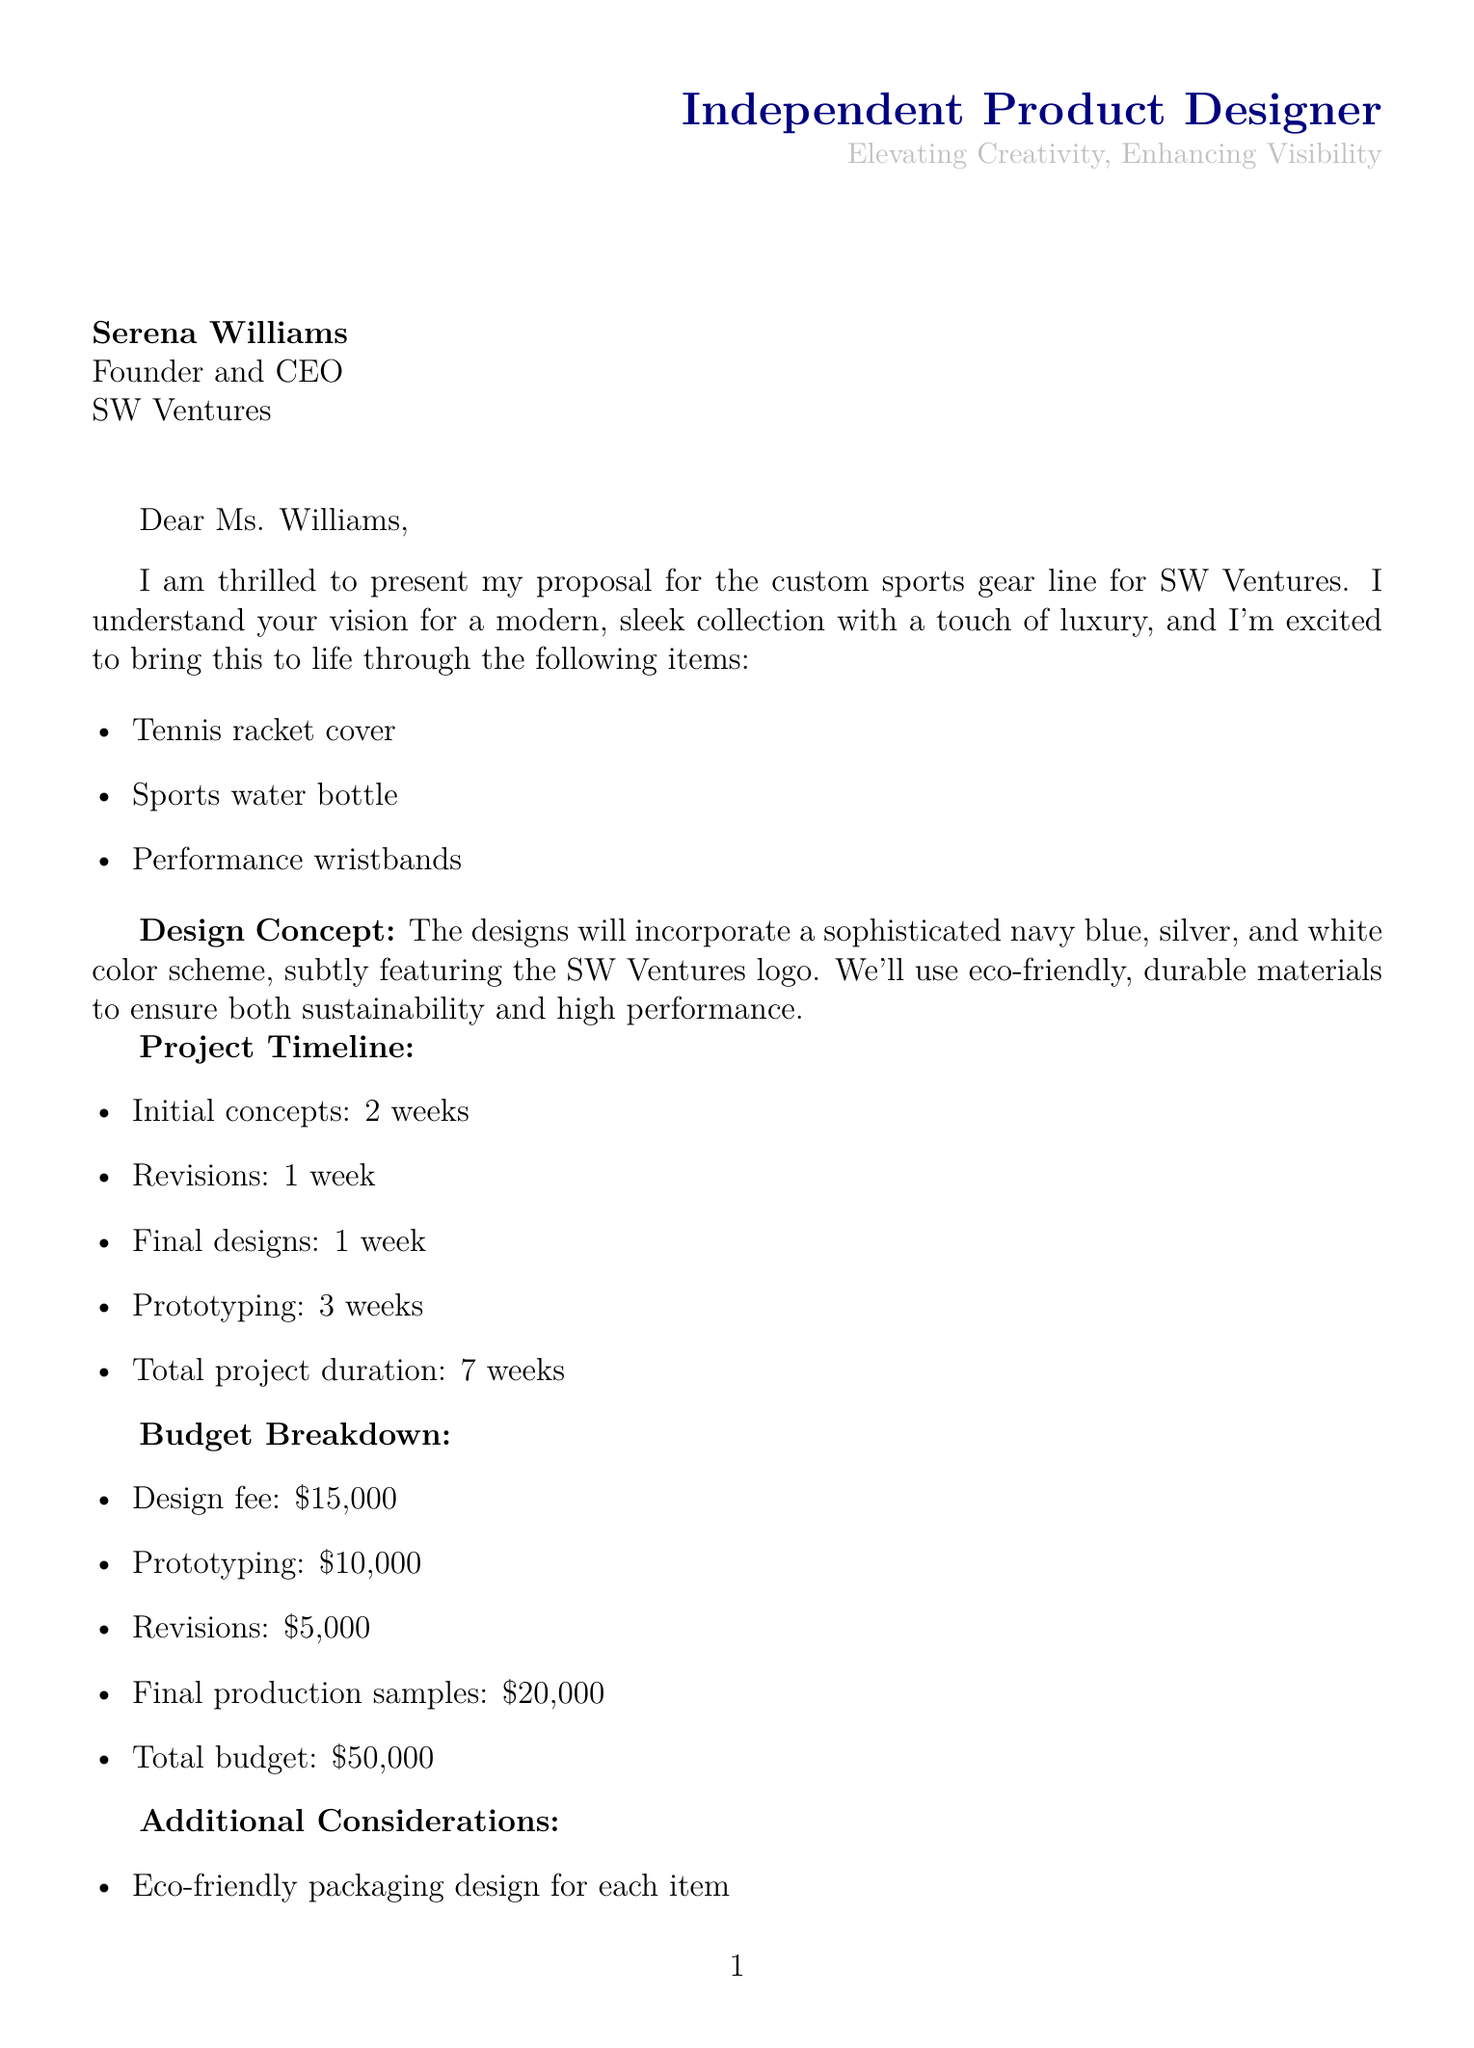What is the client's name? The client's name is mentioned at the beginning of the document.
Answer: Serena Williams What is the total budget for the project? The total budget is provided in the budget section of the document.
Answer: $50,000 How long will it take to complete the initial concepts? The timeline specifies the duration for initial concepts.
Answer: 2 weeks What is the design fee? The budget breakdown includes the design fee specifically.
Answer: $15,000 Which color scheme is specified for the custom sports gear line? The project details section states the color scheme to be used.
Answer: Navy blue, silver, and white What is the primary communication channel for project coordination? The document indicates the method of communication to be used.
Answer: Weekly video calls What specific materials are required for the designs? The design requirements detail the type of materials to be used.
Answer: Eco-friendly and durable How many items are included in the custom sports gear line? The project details section lists the number of items.
Answer: 3 items What is the exclusivity period for the designs? The additional requests specify the duration of exclusivity.
Answer: 2 years 